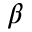Convert formula to latex. <formula><loc_0><loc_0><loc_500><loc_500>\beta</formula> 